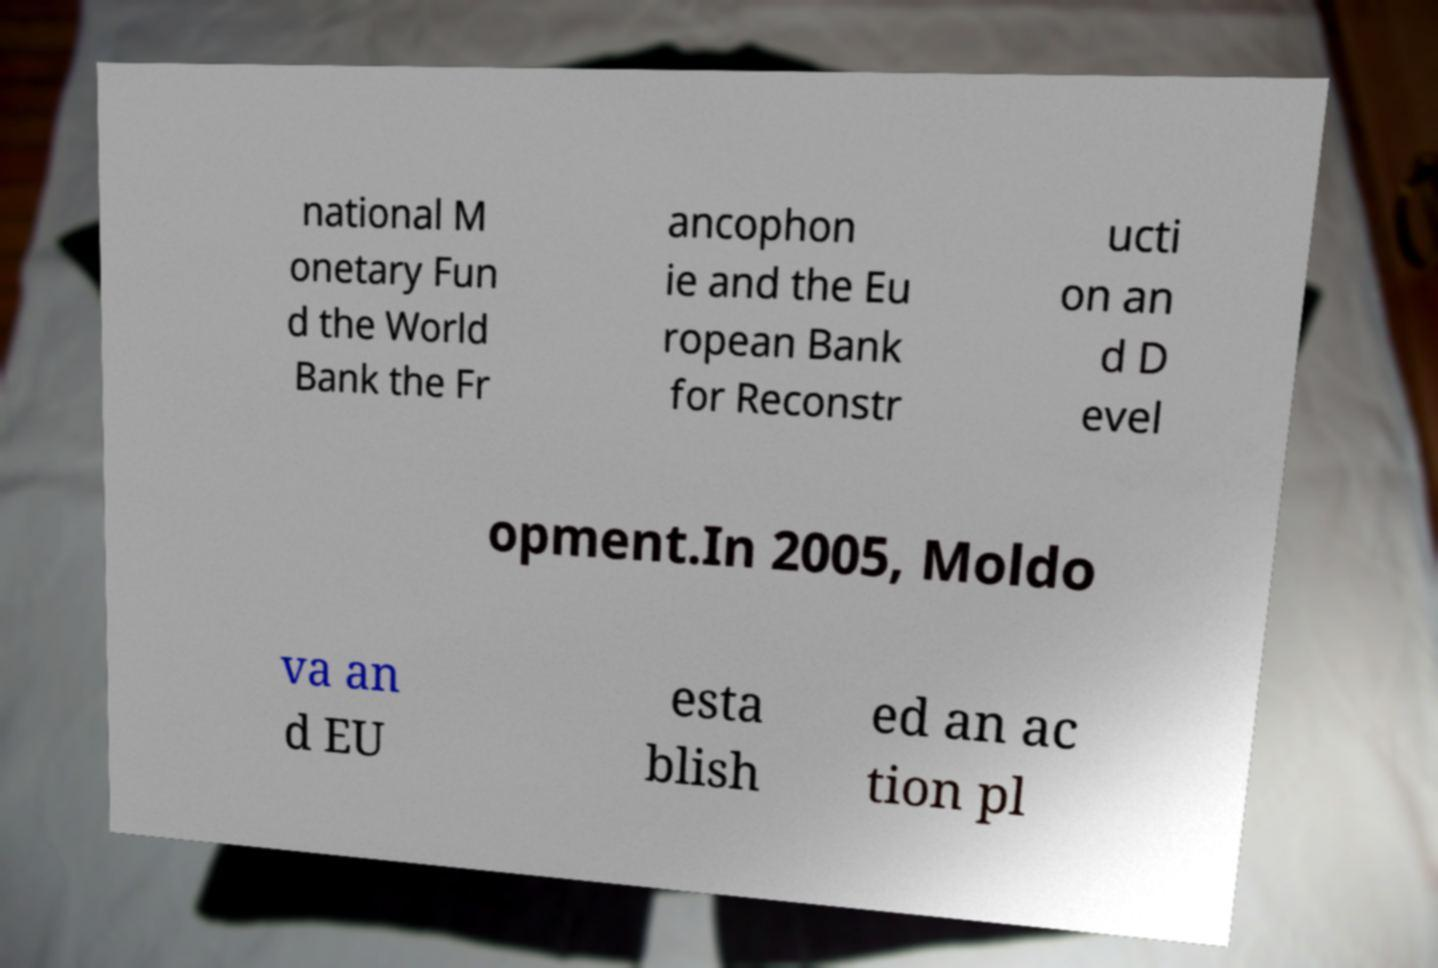Could you assist in decoding the text presented in this image and type it out clearly? national M onetary Fun d the World Bank the Fr ancophon ie and the Eu ropean Bank for Reconstr ucti on an d D evel opment.In 2005, Moldo va an d EU esta blish ed an ac tion pl 